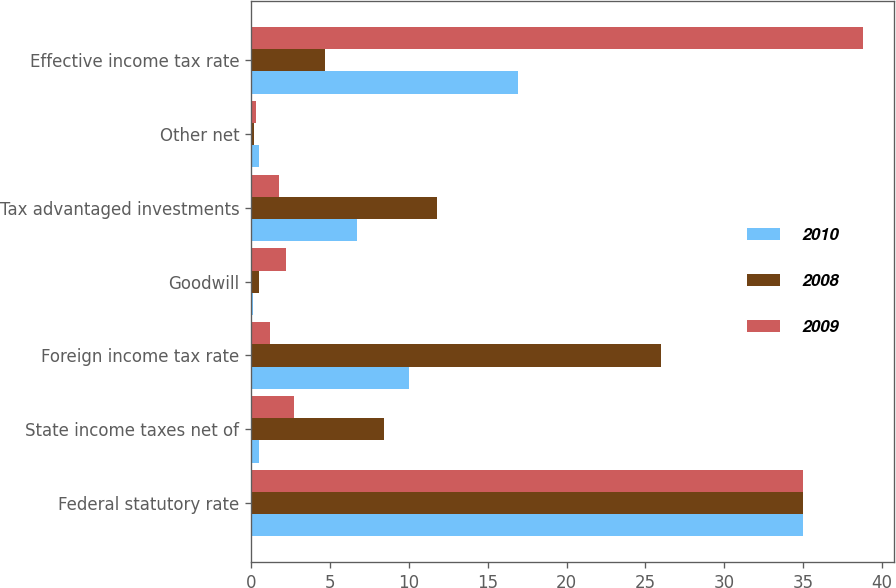<chart> <loc_0><loc_0><loc_500><loc_500><stacked_bar_chart><ecel><fcel>Federal statutory rate<fcel>State income taxes net of<fcel>Foreign income tax rate<fcel>Goodwill<fcel>Tax advantaged investments<fcel>Other net<fcel>Effective income tax rate<nl><fcel>2010<fcel>35<fcel>0.5<fcel>10<fcel>0.1<fcel>6.7<fcel>0.5<fcel>16.9<nl><fcel>2008<fcel>35<fcel>8.4<fcel>26<fcel>0.5<fcel>11.8<fcel>0.2<fcel>4.7<nl><fcel>2009<fcel>35<fcel>2.7<fcel>1.2<fcel>2.2<fcel>1.8<fcel>0.3<fcel>38.8<nl></chart> 